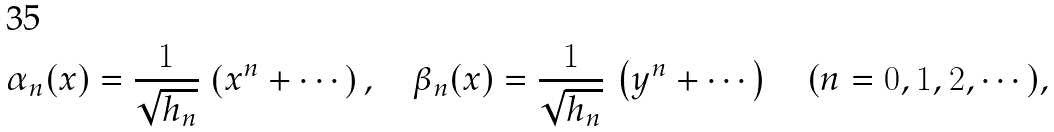<formula> <loc_0><loc_0><loc_500><loc_500>\alpha _ { n } ( x ) = \frac { 1 } { \sqrt { h _ { n } } } \, \left ( x ^ { n } + \cdots \right ) , \quad \beta _ { n } ( x ) = \frac { 1 } { \sqrt { h _ { n } } } \, \left ( y ^ { n } + \cdots \right ) \quad ( n = 0 , 1 , 2 , \cdots ) ,</formula> 